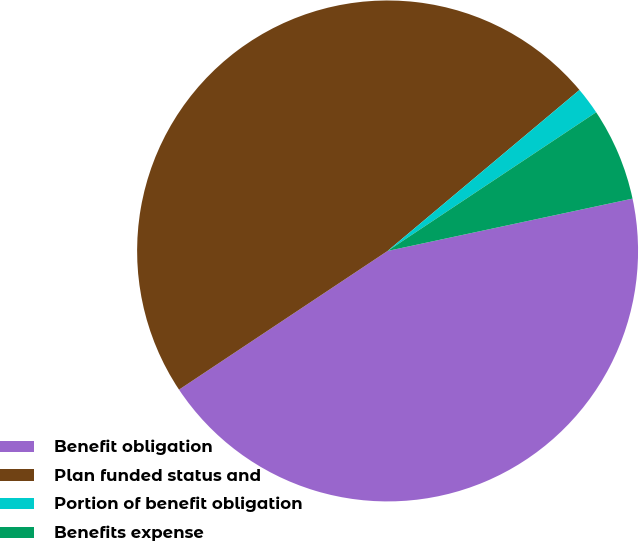Convert chart to OTSL. <chart><loc_0><loc_0><loc_500><loc_500><pie_chart><fcel>Benefit obligation<fcel>Plan funded status and<fcel>Portion of benefit obligation<fcel>Benefits expense<nl><fcel>44.01%<fcel>48.23%<fcel>1.77%<fcel>5.99%<nl></chart> 